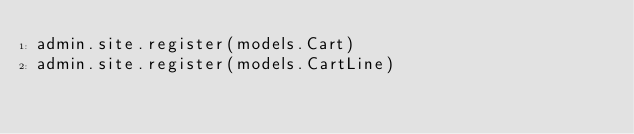Convert code to text. <code><loc_0><loc_0><loc_500><loc_500><_Python_>admin.site.register(models.Cart)
admin.site.register(models.CartLine)
</code> 